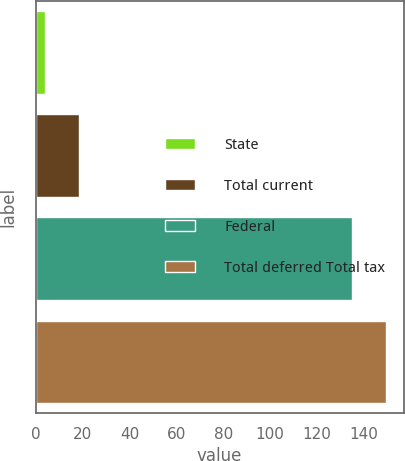<chart> <loc_0><loc_0><loc_500><loc_500><bar_chart><fcel>State<fcel>Total current<fcel>Federal<fcel>Total deferred Total tax<nl><fcel>4<fcel>18.5<fcel>135<fcel>149.5<nl></chart> 